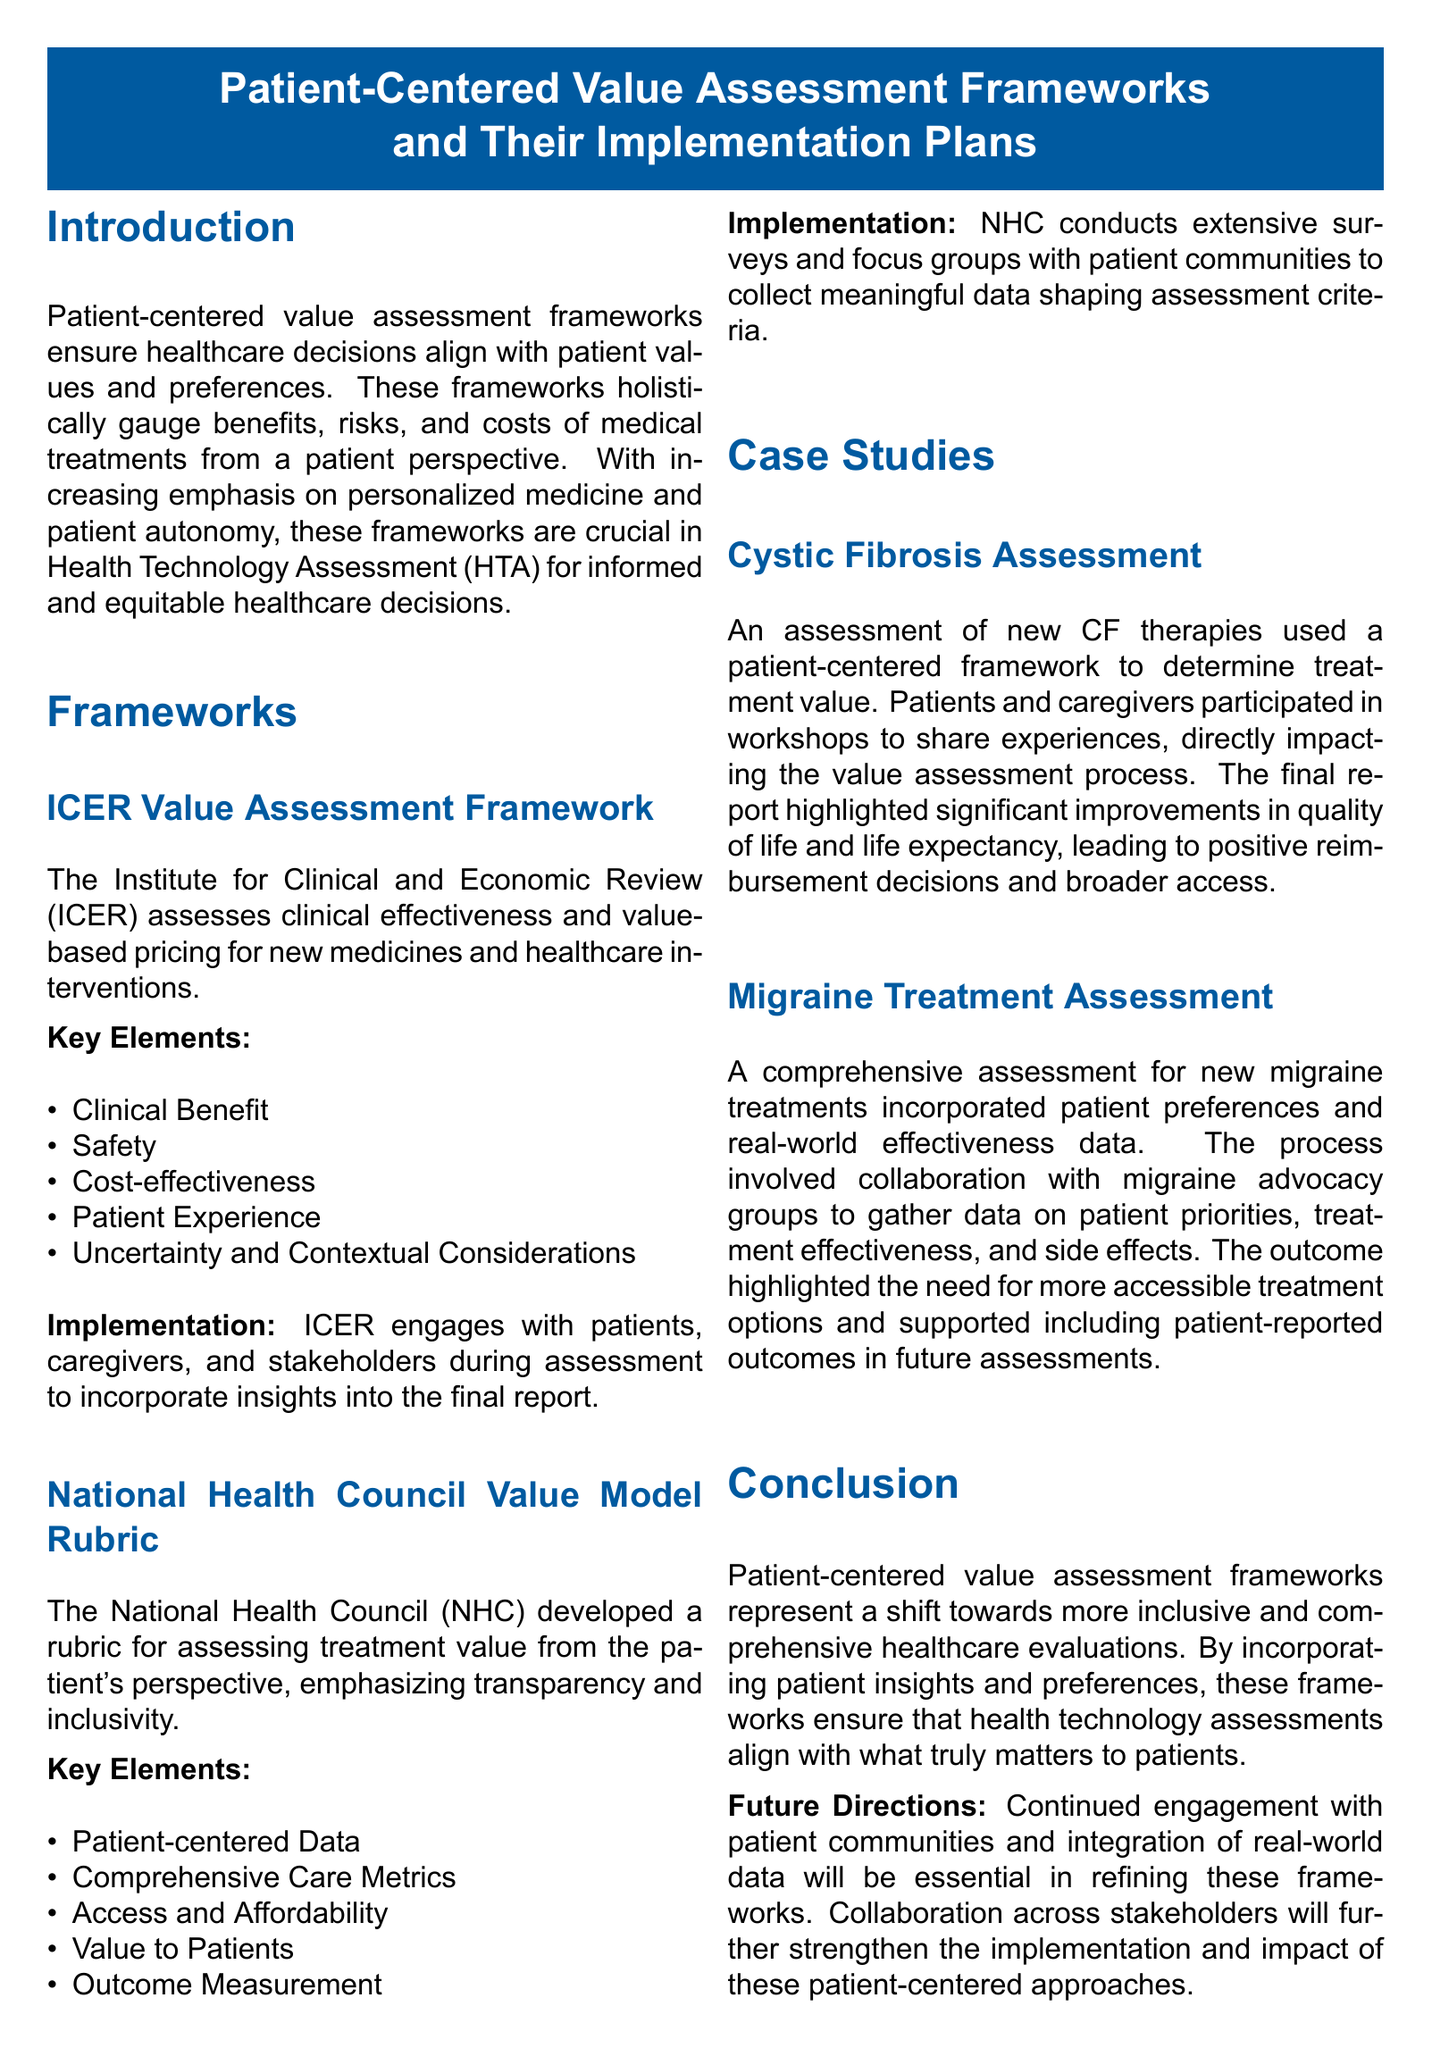what is the main focus of patient-centered value assessment frameworks? The frameworks ensure healthcare decisions align with patient values and preferences.
Answer: healthcare decisions align with patient values and preferences which organization developed the ICER Value Assessment Framework? The framework is developed by the Institute for Clinical and Economic Review.
Answer: Institute for Clinical and Economic Review what are the key elements evaluated by the ICER framework? The key elements include Clinical Benefit, Safety, Cost-effectiveness, Patient Experience, and Uncertainty and Contextual Considerations.
Answer: Clinical Benefit, Safety, Cost-effectiveness, Patient Experience, Uncertainty and Contextual Considerations who does the National Health Council conduct surveys with? The NHC conducts surveys and focus groups with patient communities.
Answer: patient communities what significant impact did the cystic fibrosis assessment report highlight? The report highlighted significant improvements in quality of life and life expectancy.
Answer: improvements in quality of life and life expectancy which types of data were incorporated in the migraine treatment assessment? The assessment included patient preferences and real-world effectiveness data.
Answer: patient preferences and real-world effectiveness data what is a future direction mentioned for patient-centered frameworks? Continued engagement with patient communities is essential.
Answer: Continued engagement with patient communities how many case studies are presented in the document? There are two case studies presented in the document: Cystic Fibrosis and Migraine Treatment.
Answer: two case studies what is emphasized in the conclusion regarding the assessment frameworks? The conclusion emphasizes the shift towards more inclusive and comprehensive healthcare evaluations.
Answer: shift towards more inclusive and comprehensive healthcare evaluations 